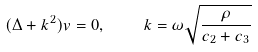<formula> <loc_0><loc_0><loc_500><loc_500>( \Delta + k ^ { 2 } ) v = 0 , \quad k = \omega \sqrt { \frac { \rho } { c _ { 2 } + c _ { 3 } } }</formula> 